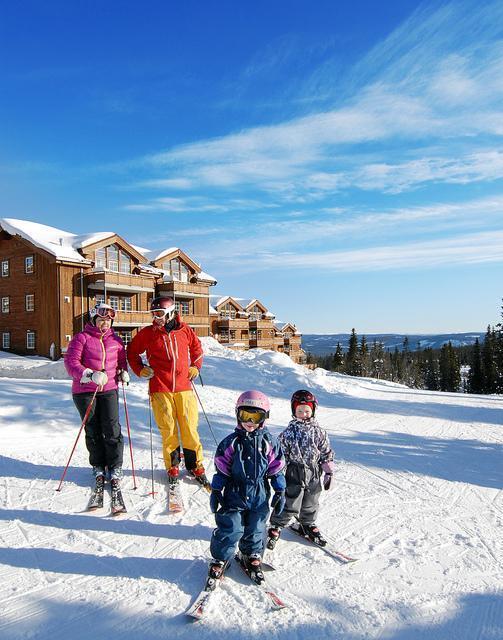How many children are there?
Give a very brief answer. 2. How many people are visible?
Give a very brief answer. 4. 